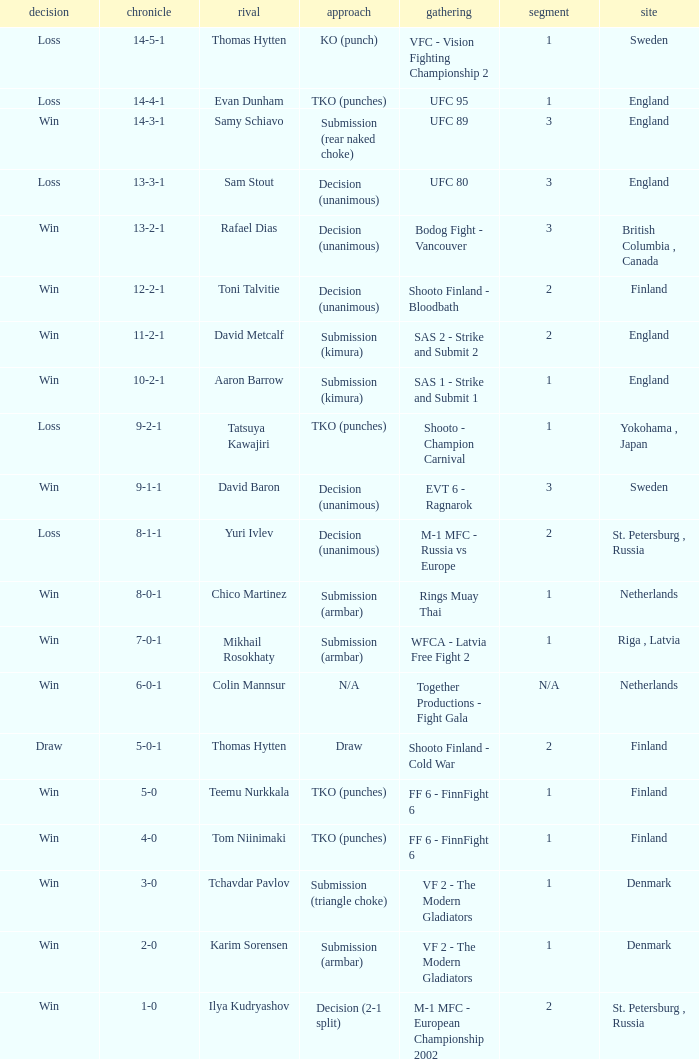What is the round in Finland with a draw for method? 2.0. 